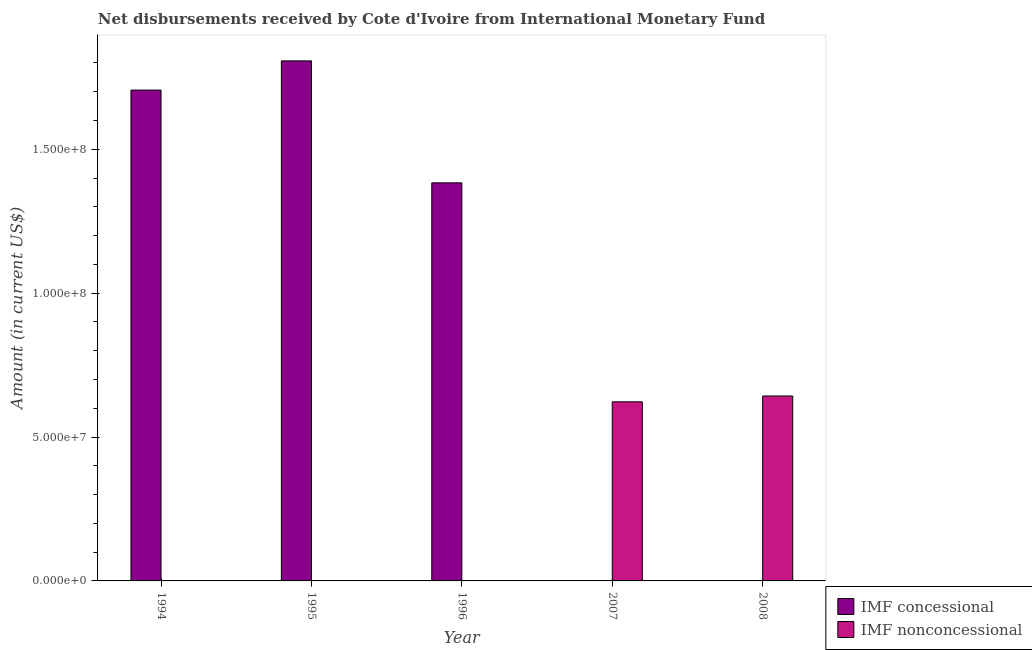How many different coloured bars are there?
Make the answer very short. 2. Are the number of bars on each tick of the X-axis equal?
Offer a very short reply. Yes. Across all years, what is the maximum net non concessional disbursements from imf?
Give a very brief answer. 6.43e+07. Across all years, what is the minimum net concessional disbursements from imf?
Give a very brief answer. 0. In which year was the net concessional disbursements from imf maximum?
Your response must be concise. 1995. What is the total net concessional disbursements from imf in the graph?
Make the answer very short. 4.90e+08. What is the difference between the net concessional disbursements from imf in 1994 and that in 1996?
Your answer should be very brief. 3.22e+07. What is the difference between the net non concessional disbursements from imf in 2008 and the net concessional disbursements from imf in 1996?
Offer a terse response. 6.43e+07. What is the average net concessional disbursements from imf per year?
Keep it short and to the point. 9.79e+07. In how many years, is the net non concessional disbursements from imf greater than 80000000 US$?
Your answer should be very brief. 0. What is the ratio of the net concessional disbursements from imf in 1994 to that in 1995?
Your answer should be very brief. 0.94. What is the difference between the highest and the second highest net concessional disbursements from imf?
Provide a short and direct response. 1.01e+07. What is the difference between the highest and the lowest net non concessional disbursements from imf?
Keep it short and to the point. 6.43e+07. In how many years, is the net non concessional disbursements from imf greater than the average net non concessional disbursements from imf taken over all years?
Provide a short and direct response. 2. Is the sum of the net non concessional disbursements from imf in 2007 and 2008 greater than the maximum net concessional disbursements from imf across all years?
Provide a short and direct response. Yes. How many bars are there?
Your response must be concise. 5. How many years are there in the graph?
Your answer should be compact. 5. Does the graph contain any zero values?
Your response must be concise. Yes. Does the graph contain grids?
Offer a terse response. No. Where does the legend appear in the graph?
Keep it short and to the point. Bottom right. How many legend labels are there?
Your answer should be very brief. 2. How are the legend labels stacked?
Keep it short and to the point. Vertical. What is the title of the graph?
Your answer should be very brief. Net disbursements received by Cote d'Ivoire from International Monetary Fund. Does "Official creditors" appear as one of the legend labels in the graph?
Provide a succinct answer. No. What is the label or title of the X-axis?
Ensure brevity in your answer.  Year. What is the Amount (in current US$) of IMF concessional in 1994?
Give a very brief answer. 1.71e+08. What is the Amount (in current US$) of IMF concessional in 1995?
Offer a terse response. 1.81e+08. What is the Amount (in current US$) of IMF concessional in 1996?
Offer a very short reply. 1.38e+08. What is the Amount (in current US$) of IMF nonconcessional in 1996?
Provide a succinct answer. 0. What is the Amount (in current US$) in IMF concessional in 2007?
Ensure brevity in your answer.  0. What is the Amount (in current US$) of IMF nonconcessional in 2007?
Give a very brief answer. 6.22e+07. What is the Amount (in current US$) of IMF concessional in 2008?
Your answer should be compact. 0. What is the Amount (in current US$) of IMF nonconcessional in 2008?
Ensure brevity in your answer.  6.43e+07. Across all years, what is the maximum Amount (in current US$) of IMF concessional?
Ensure brevity in your answer.  1.81e+08. Across all years, what is the maximum Amount (in current US$) of IMF nonconcessional?
Make the answer very short. 6.43e+07. What is the total Amount (in current US$) of IMF concessional in the graph?
Offer a terse response. 4.90e+08. What is the total Amount (in current US$) of IMF nonconcessional in the graph?
Your answer should be compact. 1.26e+08. What is the difference between the Amount (in current US$) of IMF concessional in 1994 and that in 1995?
Offer a very short reply. -1.01e+07. What is the difference between the Amount (in current US$) of IMF concessional in 1994 and that in 1996?
Make the answer very short. 3.22e+07. What is the difference between the Amount (in current US$) in IMF concessional in 1995 and that in 1996?
Your answer should be compact. 4.24e+07. What is the difference between the Amount (in current US$) of IMF nonconcessional in 2007 and that in 2008?
Your response must be concise. -2.03e+06. What is the difference between the Amount (in current US$) in IMF concessional in 1994 and the Amount (in current US$) in IMF nonconcessional in 2007?
Offer a very short reply. 1.08e+08. What is the difference between the Amount (in current US$) of IMF concessional in 1994 and the Amount (in current US$) of IMF nonconcessional in 2008?
Provide a short and direct response. 1.06e+08. What is the difference between the Amount (in current US$) of IMF concessional in 1995 and the Amount (in current US$) of IMF nonconcessional in 2007?
Your answer should be compact. 1.18e+08. What is the difference between the Amount (in current US$) in IMF concessional in 1995 and the Amount (in current US$) in IMF nonconcessional in 2008?
Keep it short and to the point. 1.16e+08. What is the difference between the Amount (in current US$) of IMF concessional in 1996 and the Amount (in current US$) of IMF nonconcessional in 2007?
Provide a short and direct response. 7.61e+07. What is the difference between the Amount (in current US$) of IMF concessional in 1996 and the Amount (in current US$) of IMF nonconcessional in 2008?
Your response must be concise. 7.41e+07. What is the average Amount (in current US$) of IMF concessional per year?
Offer a very short reply. 9.79e+07. What is the average Amount (in current US$) in IMF nonconcessional per year?
Your response must be concise. 2.53e+07. What is the ratio of the Amount (in current US$) of IMF concessional in 1994 to that in 1995?
Your answer should be very brief. 0.94. What is the ratio of the Amount (in current US$) in IMF concessional in 1994 to that in 1996?
Offer a very short reply. 1.23. What is the ratio of the Amount (in current US$) of IMF concessional in 1995 to that in 1996?
Your response must be concise. 1.31. What is the ratio of the Amount (in current US$) of IMF nonconcessional in 2007 to that in 2008?
Provide a short and direct response. 0.97. What is the difference between the highest and the second highest Amount (in current US$) in IMF concessional?
Offer a terse response. 1.01e+07. What is the difference between the highest and the lowest Amount (in current US$) in IMF concessional?
Make the answer very short. 1.81e+08. What is the difference between the highest and the lowest Amount (in current US$) in IMF nonconcessional?
Keep it short and to the point. 6.43e+07. 